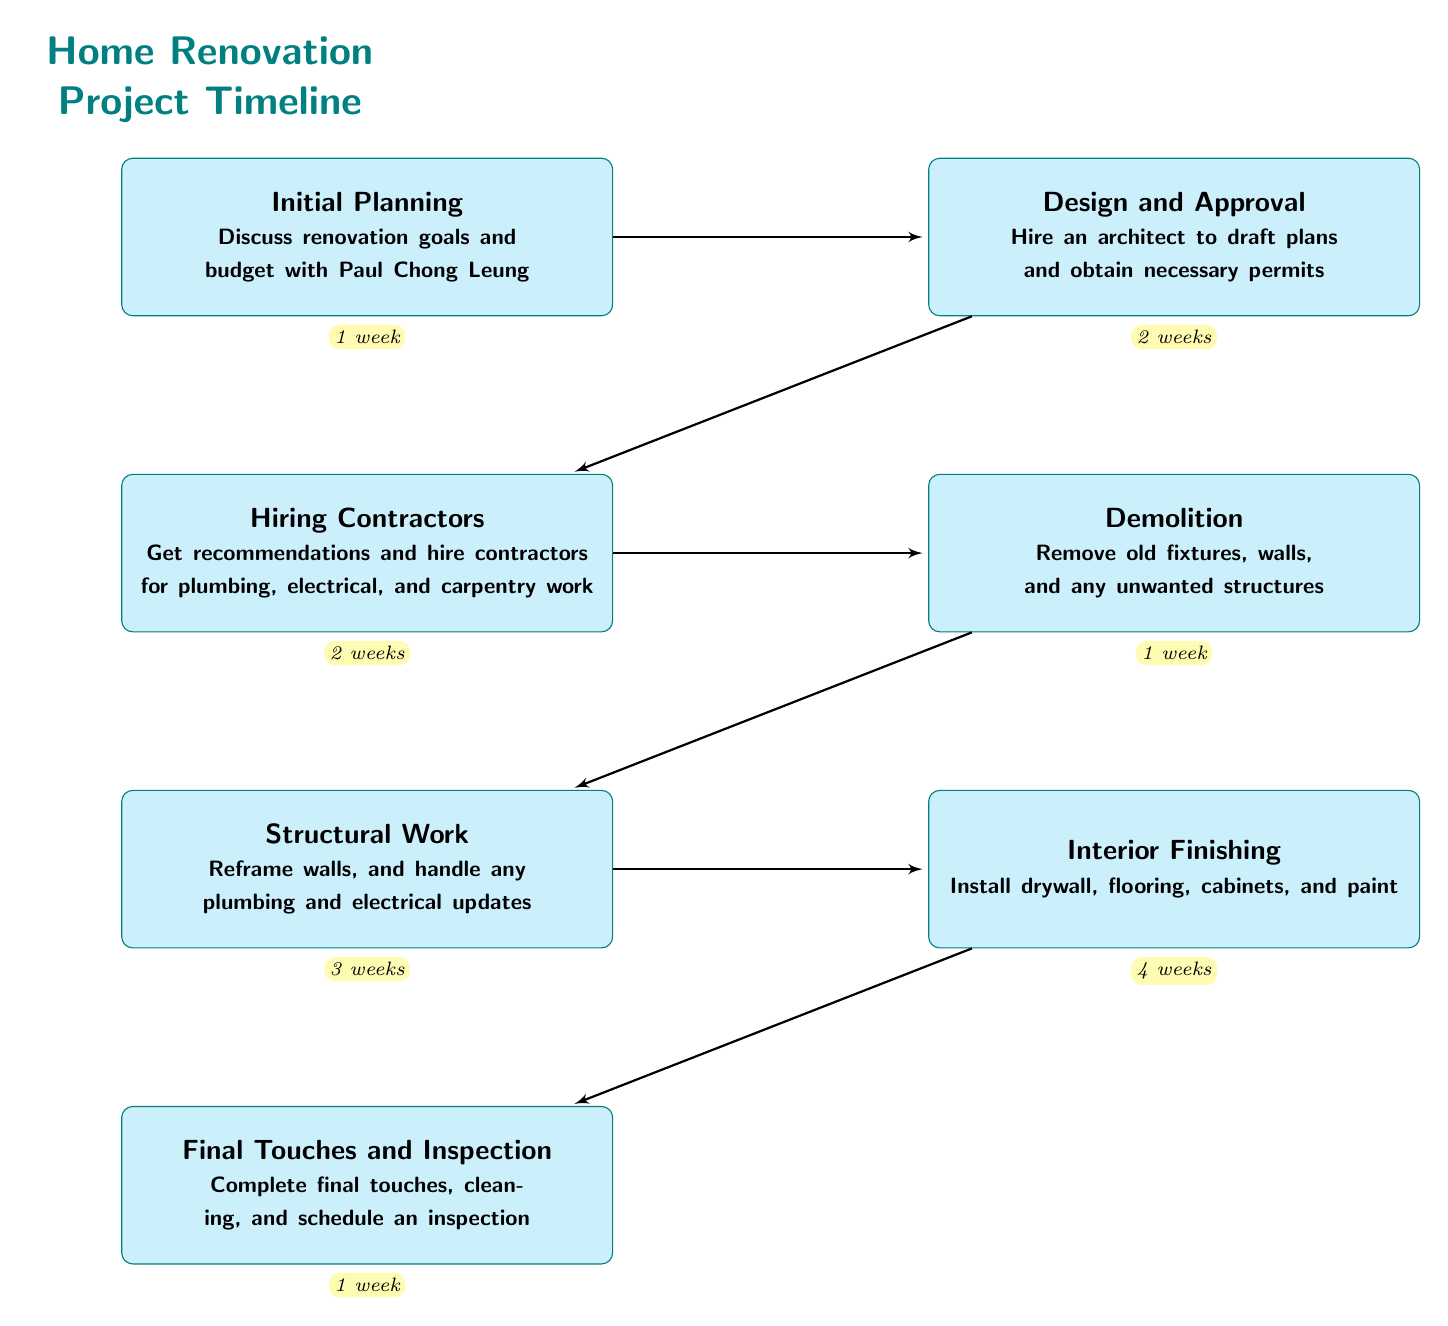What is the first step in the timeline? The flow chart starts with "Initial Planning." This is the topmost node in the diagram, indicating it is the first step of the renovation project timeline.
Answer: Initial Planning How long does "Demolition" take? Looking at the timeframe node connected to "Demolition," it shows that this step takes 1 week.
Answer: 1 week What is the last step in the renovation project? The last node at the bottom of the flow chart is "Final Touches and Inspection," indicating it is the final step in the timeline.
Answer: Final Touches and Inspection Which two steps take the same amount of time? Comparing the timeframe of "Design and Approval" (2 weeks) and "Hiring Contractors" (2 weeks), we see that both steps have the same duration.
Answer: Design and Approval, Hiring Contractors How many total steps are in the process? Counting each distinct step node in the diagram, we find there are a total of 7 distinct steps listed.
Answer: 7 What follows "Structural Work" in the timeline? The flow chart shows that "Interior Finishing" comes directly after "Structural Work," indicating the next step in the timeline.
Answer: Interior Finishing Which step requires the longest duration? Analyzing the duration of each step, "Interior Finishing" has the longest timeframe of 4 weeks among all steps in the project timeline.
Answer: 4 weeks What is the relationship between "Initial Planning" and "Design and Approval"? The flow chart connects these two nodes directly, meaning "Design and Approval" follows immediately after "Initial Planning" as its next step.
Answer: Design and Approval What is the purpose of the "Final Touches and Inspection" step? The description under this node states it involves completing final touches, cleaning, and scheduling an inspection, indicating a conclusion to the project.
Answer: Complete final touches, cleaning, and schedule an inspection 